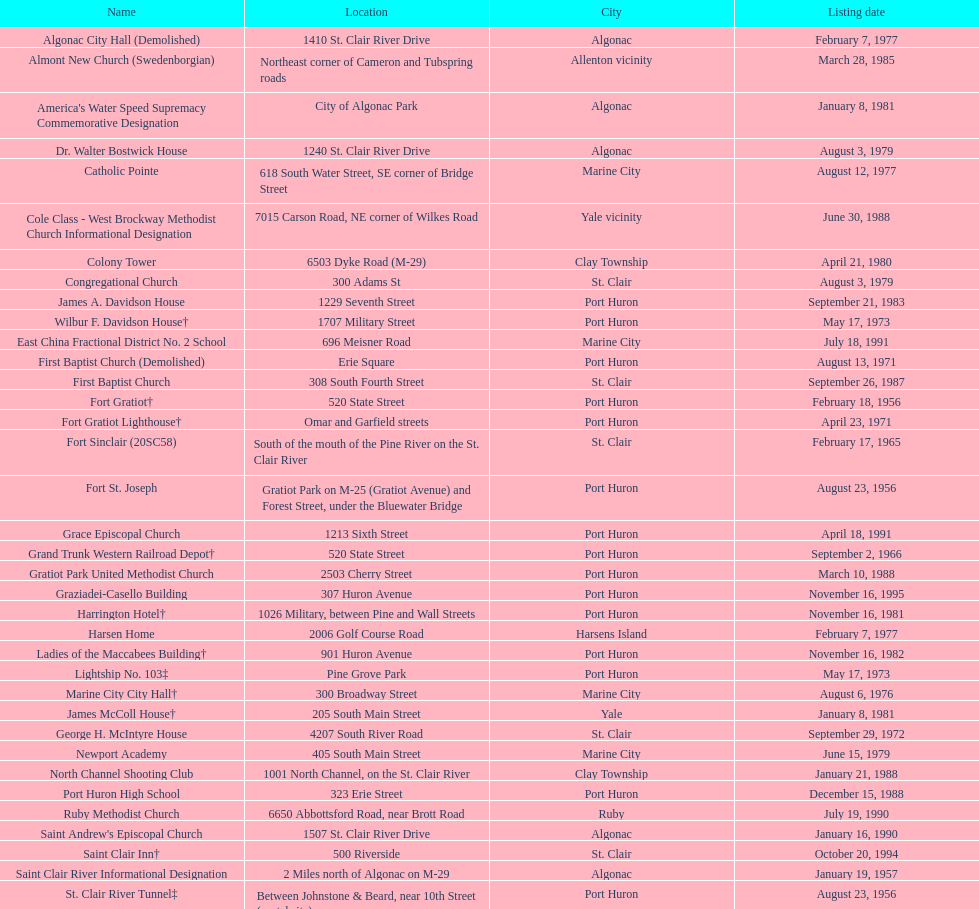Fort gratiot lighthouse and fort st. joseph are located in what city? Port Huron. 